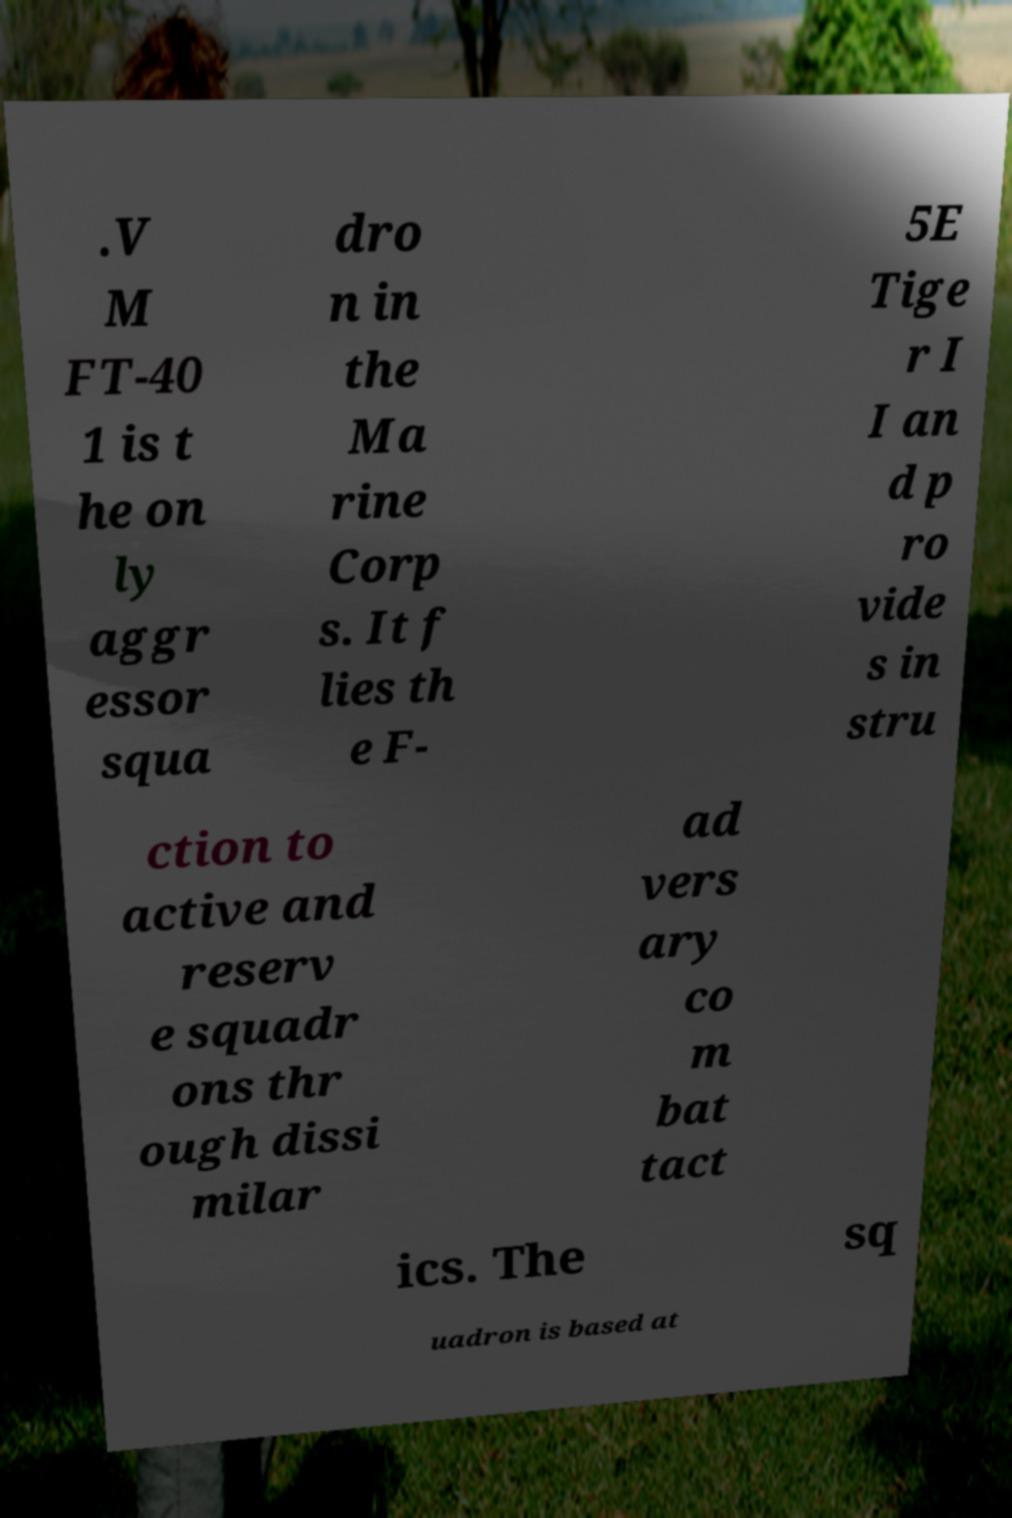There's text embedded in this image that I need extracted. Can you transcribe it verbatim? .V M FT-40 1 is t he on ly aggr essor squa dro n in the Ma rine Corp s. It f lies th e F- 5E Tige r I I an d p ro vide s in stru ction to active and reserv e squadr ons thr ough dissi milar ad vers ary co m bat tact ics. The sq uadron is based at 